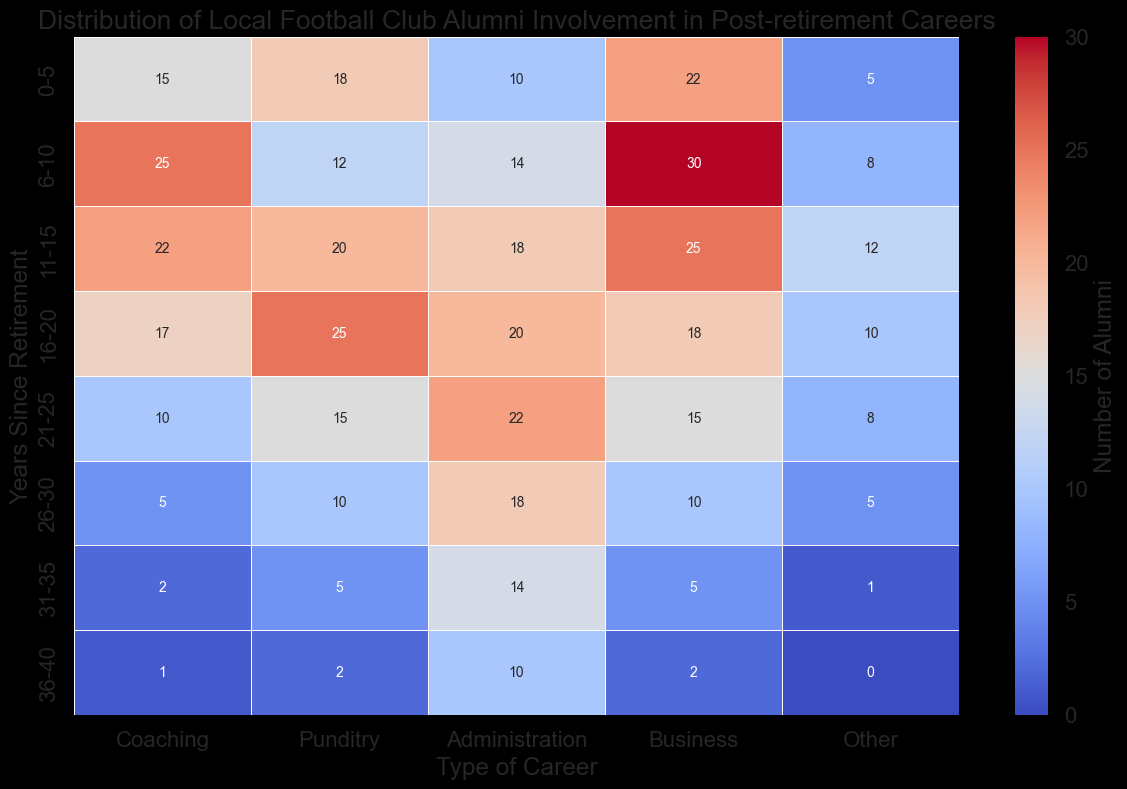Which type of career has the highest number of alumni in the 0-5 years since retirement category? Look at the row corresponding to "0-5" years and identify the highest number visually. It appears under "Business" with a count of 22.
Answer: Business Which type of career has the lowest number of alumni in the 21-25 years since retirement category? Look at the row corresponding to "21-25" years and find the smallest value. It is under "Other" with a count of 8.
Answer: Other What is the total number of alumni involved in Punditry between 16-20 and 21-25 years since retirement? Add the values from the "Punditry" column for "16-20" and "21-25" years. The values are 25 and 15. So, 25 + 15 = 40.
Answer: 40 In which years since retirement is the involvement in Coaching higher than in Business? Compare the values in "Coaching" and "Business" across each row. The rows where "Coaching" is higher than "Business" are "11-15" (22 vs 25), "16-20" (17 vs 18), and "21-25" (10 vs 15).
Answer: None Which category experiences a consistent decline in alumni involvement as years since retirement increases? Check each column and observe the trend of numbers. The "Coaching" category consistently declines as the years increase, going from 15 to 1.
Answer: Coaching What is the average number of alumni involved in Administration across all years since retirement? Sum the values in the "Administration" column and divide by the number of rows (8). The sum is 10 + 14 + 18 + 20 + 22 + 18 + 14 + 10 = 126. The average is 126 / 8 = 15.75.
Answer: 15.75 Which type of career shows the most visual variability in alumni involvement across different years since retirement? Look at the heatmap visually and identify which column has the most varying colors. "Business" has a wide range from very low (2) to very high (30), indicating high variability.
Answer: Business What is the percentage increase in the number of alumni in Administration from 0-5 to 6-10 years since retirement? Find the values for "0-5" and "6-10" in "Administration" which are 10 and 14. The increase is 14 - 10 = 4, and the percentage increase is (4/10)*100 = 40%.
Answer: 40% What is the median number of alumni involved in Other careers across all years since retirement? List the values in "Other" and find the median: 5, 8, 12, 10, 8, 5, 1, 0. The median is the average of the two middle numbers (8 and 8), which is (8+8)/2 = 8.
Answer: 8 